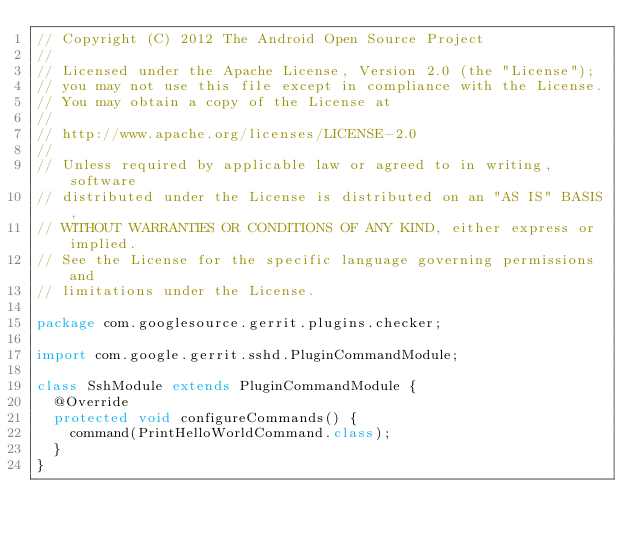<code> <loc_0><loc_0><loc_500><loc_500><_Java_>// Copyright (C) 2012 The Android Open Source Project
//
// Licensed under the Apache License, Version 2.0 (the "License");
// you may not use this file except in compliance with the License.
// You may obtain a copy of the License at
//
// http://www.apache.org/licenses/LICENSE-2.0
//
// Unless required by applicable law or agreed to in writing, software
// distributed under the License is distributed on an "AS IS" BASIS,
// WITHOUT WARRANTIES OR CONDITIONS OF ANY KIND, either express or implied.
// See the License for the specific language governing permissions and
// limitations under the License.

package com.googlesource.gerrit.plugins.checker;

import com.google.gerrit.sshd.PluginCommandModule;

class SshModule extends PluginCommandModule {
  @Override
  protected void configureCommands() {
    command(PrintHelloWorldCommand.class);
  }
}
</code> 